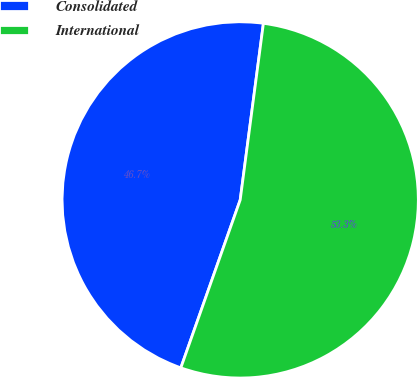Convert chart to OTSL. <chart><loc_0><loc_0><loc_500><loc_500><pie_chart><fcel>Consolidated<fcel>International<nl><fcel>46.67%<fcel>53.33%<nl></chart> 